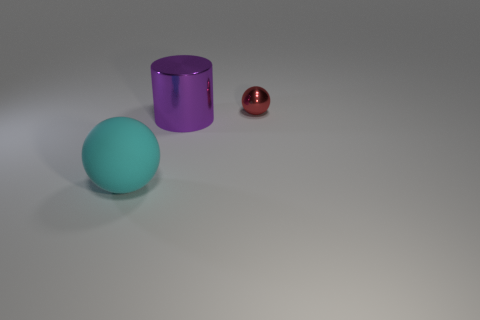What size is the red thing that is the same shape as the cyan object?
Your answer should be compact. Small. Are there any other things that have the same size as the metal cylinder?
Your answer should be very brief. Yes. Are there fewer large balls behind the cyan object than green cylinders?
Give a very brief answer. No. Do the purple object and the tiny metal thing have the same shape?
Make the answer very short. No. What is the color of the other thing that is the same shape as the small object?
Your answer should be compact. Cyan. What number of other tiny balls have the same color as the tiny metal sphere?
Offer a terse response. 0. How many things are either big things that are left of the purple cylinder or small blue matte things?
Your answer should be compact. 1. There is a sphere in front of the purple cylinder; what size is it?
Keep it short and to the point. Large. Are there fewer big cyan objects than yellow metallic spheres?
Provide a succinct answer. No. Are the sphere that is behind the purple cylinder and the big object behind the big cyan matte sphere made of the same material?
Give a very brief answer. Yes. 